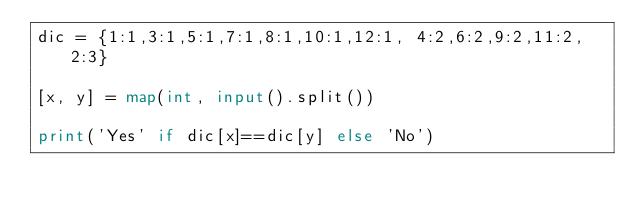<code> <loc_0><loc_0><loc_500><loc_500><_Python_>dic = {1:1,3:1,5:1,7:1,8:1,10:1,12:1, 4:2,6:2,9:2,11:2, 2:3}

[x, y] = map(int, input().split())

print('Yes' if dic[x]==dic[y] else 'No')
</code> 